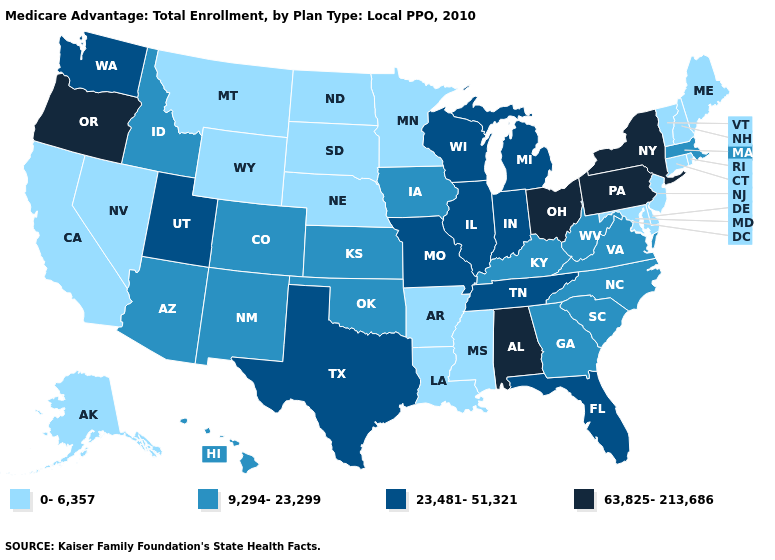How many symbols are there in the legend?
Concise answer only. 4. Name the states that have a value in the range 23,481-51,321?
Answer briefly. Florida, Illinois, Indiana, Michigan, Missouri, Tennessee, Texas, Utah, Washington, Wisconsin. Does Delaware have the highest value in the South?
Concise answer only. No. Does the first symbol in the legend represent the smallest category?
Answer briefly. Yes. What is the highest value in states that border Michigan?
Answer briefly. 63,825-213,686. Among the states that border North Carolina , does South Carolina have the lowest value?
Be succinct. Yes. What is the value of Massachusetts?
Be succinct. 9,294-23,299. Name the states that have a value in the range 63,825-213,686?
Write a very short answer. Alabama, New York, Ohio, Oregon, Pennsylvania. Name the states that have a value in the range 9,294-23,299?
Give a very brief answer. Arizona, Colorado, Georgia, Hawaii, Iowa, Idaho, Kansas, Kentucky, Massachusetts, North Carolina, New Mexico, Oklahoma, South Carolina, Virginia, West Virginia. Among the states that border Missouri , does Nebraska have the lowest value?
Be succinct. Yes. Does Colorado have the same value as Maryland?
Write a very short answer. No. Name the states that have a value in the range 9,294-23,299?
Be succinct. Arizona, Colorado, Georgia, Hawaii, Iowa, Idaho, Kansas, Kentucky, Massachusetts, North Carolina, New Mexico, Oklahoma, South Carolina, Virginia, West Virginia. Does Kentucky have the same value as Nebraska?
Be succinct. No. Name the states that have a value in the range 23,481-51,321?
Quick response, please. Florida, Illinois, Indiana, Michigan, Missouri, Tennessee, Texas, Utah, Washington, Wisconsin. Does the first symbol in the legend represent the smallest category?
Answer briefly. Yes. 